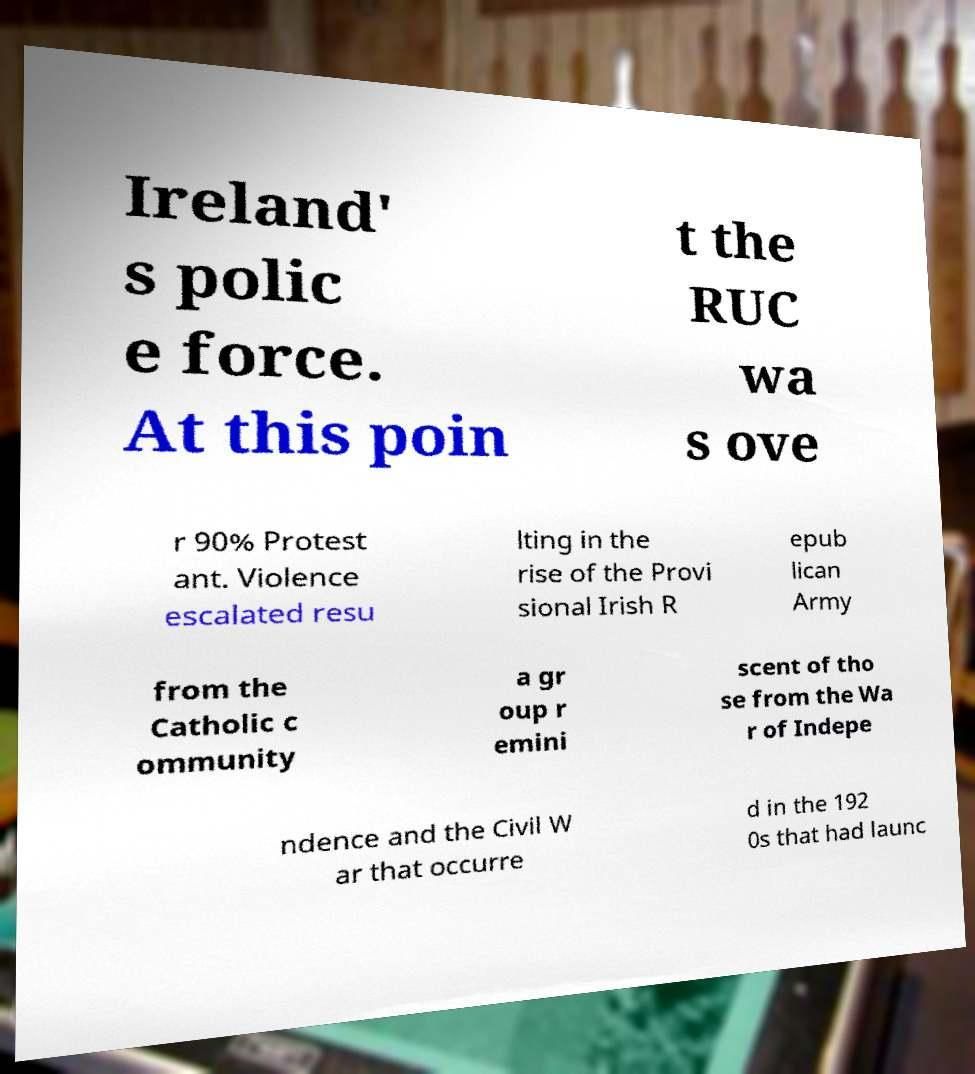What messages or text are displayed in this image? I need them in a readable, typed format. Ireland' s polic e force. At this poin t the RUC wa s ove r 90% Protest ant. Violence escalated resu lting in the rise of the Provi sional Irish R epub lican Army from the Catholic c ommunity a gr oup r emini scent of tho se from the Wa r of Indepe ndence and the Civil W ar that occurre d in the 192 0s that had launc 